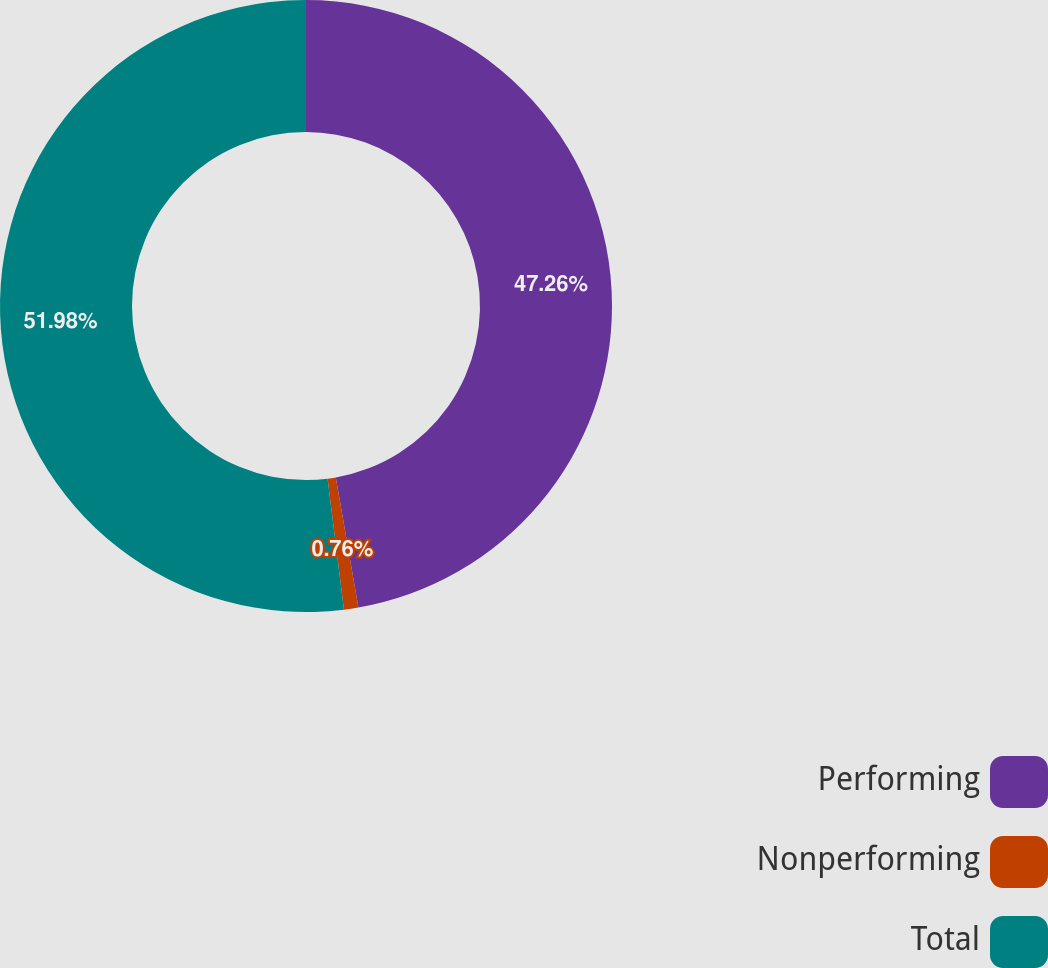<chart> <loc_0><loc_0><loc_500><loc_500><pie_chart><fcel>Performing<fcel>Nonperforming<fcel>Total<nl><fcel>47.26%<fcel>0.76%<fcel>51.98%<nl></chart> 